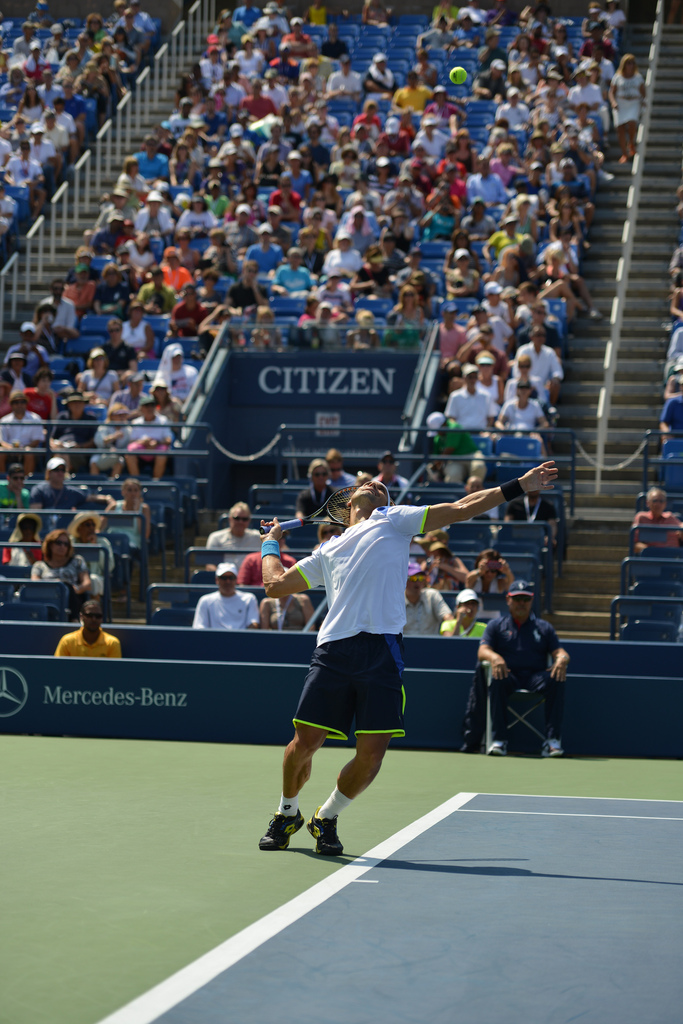Please provide a short description for this region: [0.66, 0.56, 0.69, 0.58]. The region described encompasses a small area focusing on the player's headgear. It specifically points to a sporty blue baseball cap worn by the man. This accessory is crucial for shielding his eyes from the sun during the tennis match. 